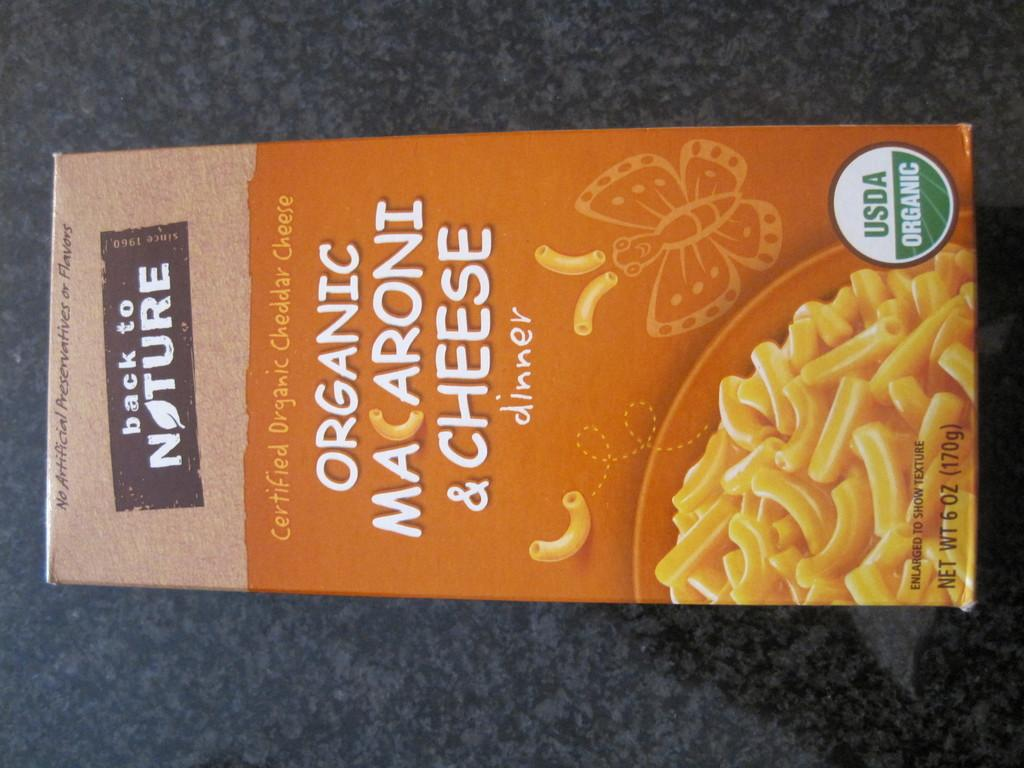<image>
Summarize the visual content of the image. Back to nature mac n cheese organic box 